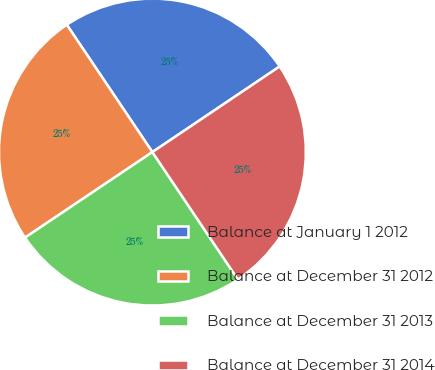Convert chart to OTSL. <chart><loc_0><loc_0><loc_500><loc_500><pie_chart><fcel>Balance at January 1 2012<fcel>Balance at December 31 2012<fcel>Balance at December 31 2013<fcel>Balance at December 31 2014<nl><fcel>24.99%<fcel>24.99%<fcel>25.0%<fcel>25.01%<nl></chart> 